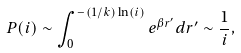<formula> <loc_0><loc_0><loc_500><loc_500>P ( i ) \sim \int _ { 0 } ^ { - ( 1 / k ) \ln ( i ) } e ^ { \beta r ^ { \prime } } d r ^ { \prime } \sim \frac { 1 } { i } ,</formula> 